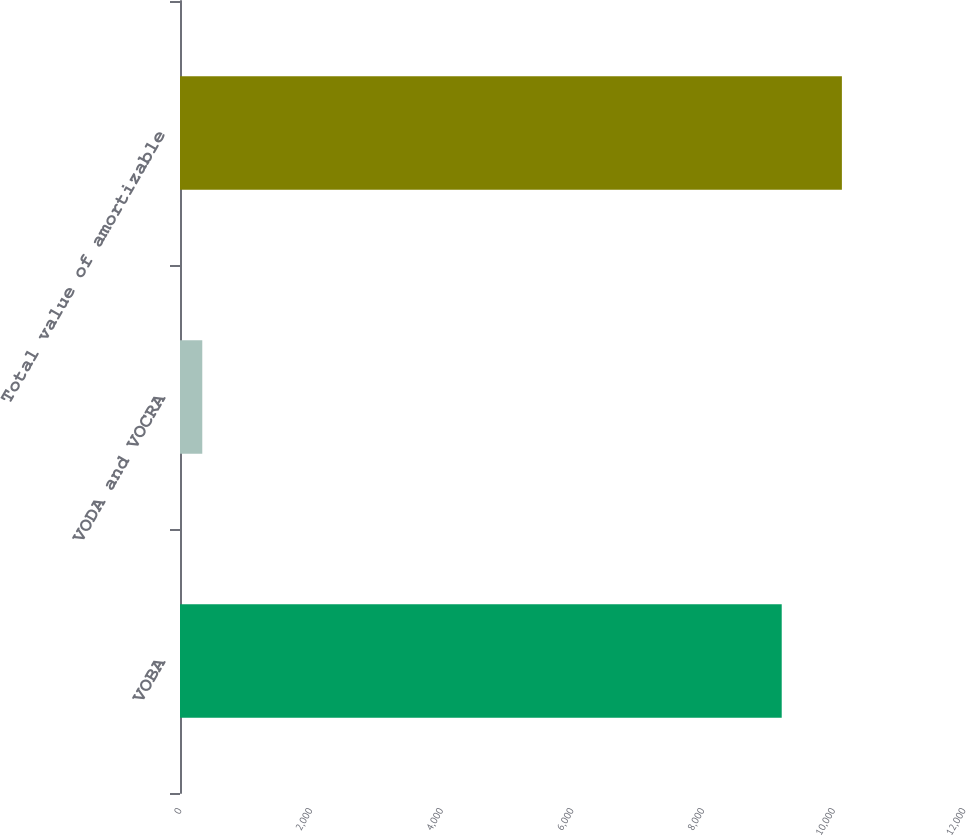Convert chart to OTSL. <chart><loc_0><loc_0><loc_500><loc_500><bar_chart><fcel>VOBA<fcel>VODA and VOCRA<fcel>Total value of amortizable<nl><fcel>9210<fcel>341<fcel>10131<nl></chart> 